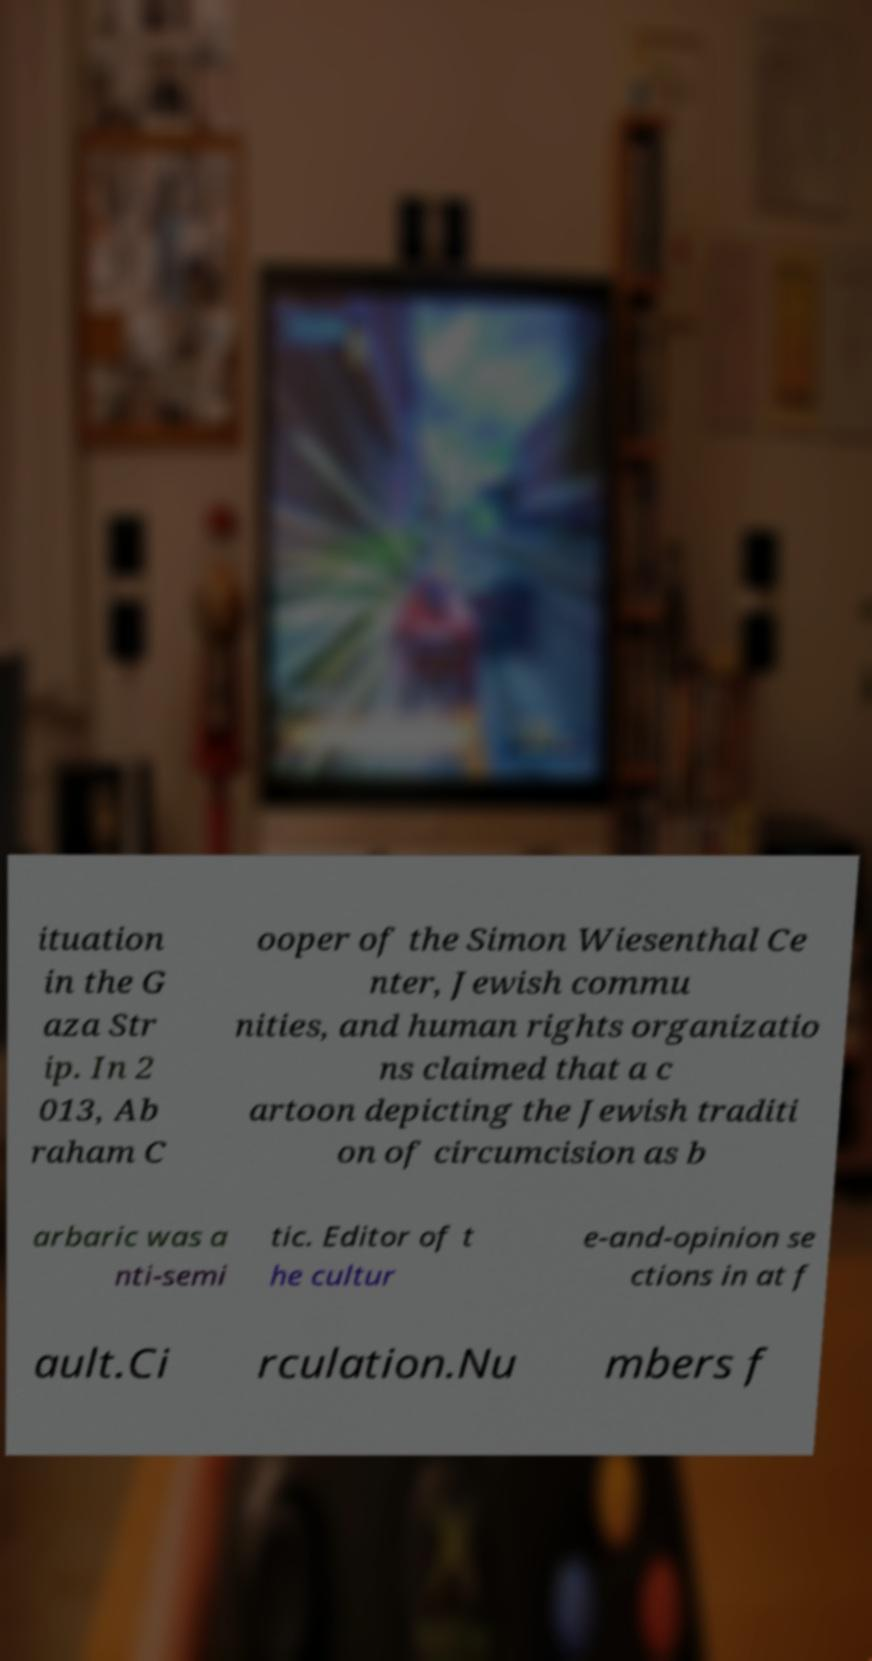I need the written content from this picture converted into text. Can you do that? ituation in the G aza Str ip. In 2 013, Ab raham C ooper of the Simon Wiesenthal Ce nter, Jewish commu nities, and human rights organizatio ns claimed that a c artoon depicting the Jewish traditi on of circumcision as b arbaric was a nti-semi tic. Editor of t he cultur e-and-opinion se ctions in at f ault.Ci rculation.Nu mbers f 